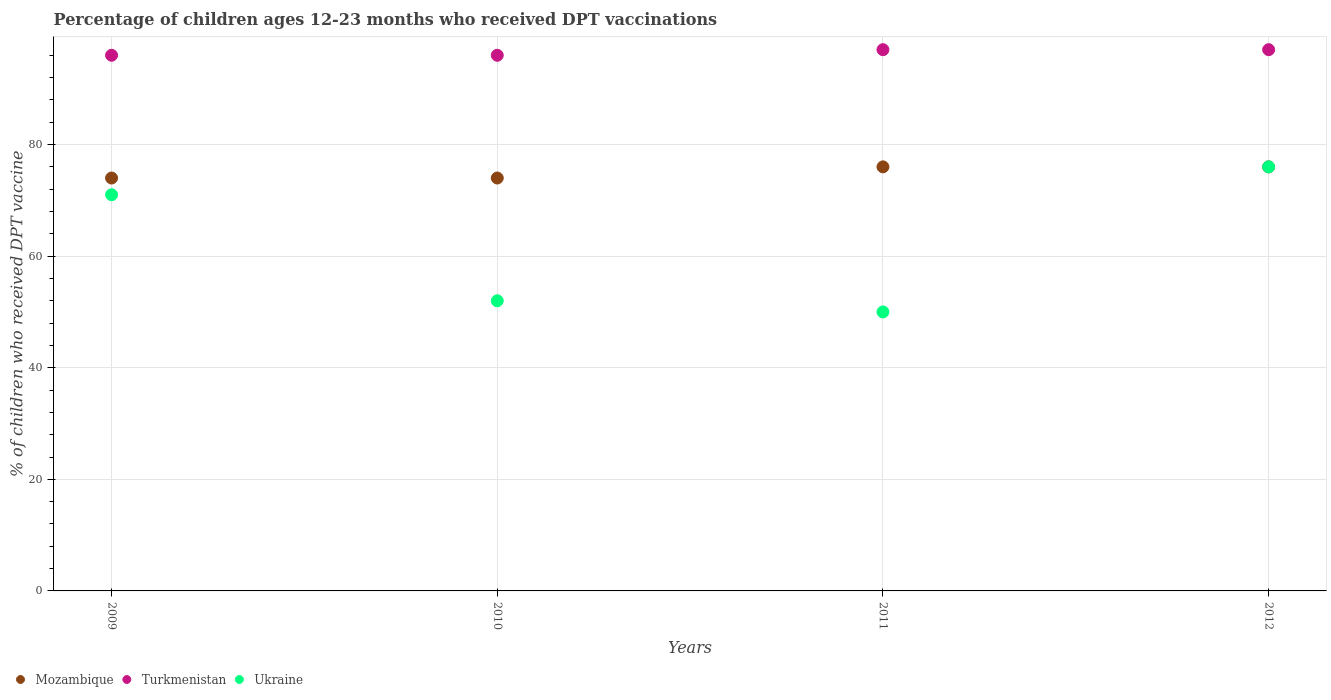How many different coloured dotlines are there?
Offer a very short reply. 3. Is the number of dotlines equal to the number of legend labels?
Offer a very short reply. Yes. Across all years, what is the maximum percentage of children who received DPT vaccination in Mozambique?
Offer a very short reply. 76. Across all years, what is the minimum percentage of children who received DPT vaccination in Mozambique?
Your response must be concise. 74. What is the total percentage of children who received DPT vaccination in Ukraine in the graph?
Your answer should be compact. 249. What is the difference between the percentage of children who received DPT vaccination in Mozambique in 2011 and that in 2012?
Provide a short and direct response. 0. In how many years, is the percentage of children who received DPT vaccination in Turkmenistan greater than 32 %?
Give a very brief answer. 4. What is the ratio of the percentage of children who received DPT vaccination in Turkmenistan in 2010 to that in 2012?
Your answer should be very brief. 0.99. Is the percentage of children who received DPT vaccination in Mozambique in 2009 less than that in 2011?
Your answer should be compact. Yes. What is the difference between the highest and the lowest percentage of children who received DPT vaccination in Mozambique?
Offer a terse response. 2. Is the sum of the percentage of children who received DPT vaccination in Mozambique in 2009 and 2011 greater than the maximum percentage of children who received DPT vaccination in Turkmenistan across all years?
Give a very brief answer. Yes. Is it the case that in every year, the sum of the percentage of children who received DPT vaccination in Turkmenistan and percentage of children who received DPT vaccination in Mozambique  is greater than the percentage of children who received DPT vaccination in Ukraine?
Make the answer very short. Yes. Does the percentage of children who received DPT vaccination in Turkmenistan monotonically increase over the years?
Your answer should be very brief. No. Where does the legend appear in the graph?
Make the answer very short. Bottom left. How many legend labels are there?
Keep it short and to the point. 3. How are the legend labels stacked?
Ensure brevity in your answer.  Horizontal. What is the title of the graph?
Your answer should be very brief. Percentage of children ages 12-23 months who received DPT vaccinations. Does "High income: OECD" appear as one of the legend labels in the graph?
Give a very brief answer. No. What is the label or title of the Y-axis?
Provide a short and direct response. % of children who received DPT vaccine. What is the % of children who received DPT vaccine of Turkmenistan in 2009?
Give a very brief answer. 96. What is the % of children who received DPT vaccine in Turkmenistan in 2010?
Your answer should be very brief. 96. What is the % of children who received DPT vaccine in Mozambique in 2011?
Your response must be concise. 76. What is the % of children who received DPT vaccine of Turkmenistan in 2011?
Offer a terse response. 97. What is the % of children who received DPT vaccine of Turkmenistan in 2012?
Keep it short and to the point. 97. Across all years, what is the maximum % of children who received DPT vaccine in Mozambique?
Offer a very short reply. 76. Across all years, what is the maximum % of children who received DPT vaccine of Turkmenistan?
Offer a very short reply. 97. Across all years, what is the minimum % of children who received DPT vaccine in Mozambique?
Provide a succinct answer. 74. Across all years, what is the minimum % of children who received DPT vaccine in Turkmenistan?
Offer a terse response. 96. What is the total % of children who received DPT vaccine of Mozambique in the graph?
Give a very brief answer. 300. What is the total % of children who received DPT vaccine in Turkmenistan in the graph?
Ensure brevity in your answer.  386. What is the total % of children who received DPT vaccine of Ukraine in the graph?
Offer a terse response. 249. What is the difference between the % of children who received DPT vaccine of Turkmenistan in 2009 and that in 2010?
Ensure brevity in your answer.  0. What is the difference between the % of children who received DPT vaccine in Ukraine in 2009 and that in 2010?
Keep it short and to the point. 19. What is the difference between the % of children who received DPT vaccine in Mozambique in 2009 and that in 2011?
Ensure brevity in your answer.  -2. What is the difference between the % of children who received DPT vaccine in Turkmenistan in 2010 and that in 2011?
Offer a terse response. -1. What is the difference between the % of children who received DPT vaccine in Mozambique in 2010 and that in 2012?
Your response must be concise. -2. What is the difference between the % of children who received DPT vaccine in Ukraine in 2010 and that in 2012?
Keep it short and to the point. -24. What is the difference between the % of children who received DPT vaccine of Turkmenistan in 2011 and that in 2012?
Provide a succinct answer. 0. What is the difference between the % of children who received DPT vaccine in Mozambique in 2009 and the % of children who received DPT vaccine in Turkmenistan in 2011?
Provide a succinct answer. -23. What is the difference between the % of children who received DPT vaccine in Mozambique in 2009 and the % of children who received DPT vaccine in Ukraine in 2012?
Provide a short and direct response. -2. What is the difference between the % of children who received DPT vaccine in Turkmenistan in 2009 and the % of children who received DPT vaccine in Ukraine in 2012?
Your answer should be compact. 20. What is the difference between the % of children who received DPT vaccine of Mozambique in 2010 and the % of children who received DPT vaccine of Turkmenistan in 2011?
Offer a very short reply. -23. What is the difference between the % of children who received DPT vaccine in Turkmenistan in 2010 and the % of children who received DPT vaccine in Ukraine in 2011?
Keep it short and to the point. 46. What is the difference between the % of children who received DPT vaccine in Mozambique in 2010 and the % of children who received DPT vaccine in Turkmenistan in 2012?
Offer a very short reply. -23. What is the difference between the % of children who received DPT vaccine of Mozambique in 2010 and the % of children who received DPT vaccine of Ukraine in 2012?
Your response must be concise. -2. What is the difference between the % of children who received DPT vaccine in Turkmenistan in 2010 and the % of children who received DPT vaccine in Ukraine in 2012?
Provide a succinct answer. 20. What is the difference between the % of children who received DPT vaccine of Mozambique in 2011 and the % of children who received DPT vaccine of Ukraine in 2012?
Keep it short and to the point. 0. What is the difference between the % of children who received DPT vaccine in Turkmenistan in 2011 and the % of children who received DPT vaccine in Ukraine in 2012?
Give a very brief answer. 21. What is the average % of children who received DPT vaccine of Mozambique per year?
Make the answer very short. 75. What is the average % of children who received DPT vaccine in Turkmenistan per year?
Make the answer very short. 96.5. What is the average % of children who received DPT vaccine in Ukraine per year?
Your answer should be very brief. 62.25. In the year 2009, what is the difference between the % of children who received DPT vaccine of Mozambique and % of children who received DPT vaccine of Turkmenistan?
Offer a terse response. -22. In the year 2009, what is the difference between the % of children who received DPT vaccine of Mozambique and % of children who received DPT vaccine of Ukraine?
Provide a succinct answer. 3. In the year 2009, what is the difference between the % of children who received DPT vaccine in Turkmenistan and % of children who received DPT vaccine in Ukraine?
Provide a succinct answer. 25. In the year 2010, what is the difference between the % of children who received DPT vaccine of Mozambique and % of children who received DPT vaccine of Turkmenistan?
Keep it short and to the point. -22. In the year 2010, what is the difference between the % of children who received DPT vaccine of Mozambique and % of children who received DPT vaccine of Ukraine?
Your answer should be compact. 22. In the year 2011, what is the difference between the % of children who received DPT vaccine of Mozambique and % of children who received DPT vaccine of Turkmenistan?
Ensure brevity in your answer.  -21. In the year 2011, what is the difference between the % of children who received DPT vaccine of Mozambique and % of children who received DPT vaccine of Ukraine?
Ensure brevity in your answer.  26. In the year 2011, what is the difference between the % of children who received DPT vaccine in Turkmenistan and % of children who received DPT vaccine in Ukraine?
Your answer should be very brief. 47. In the year 2012, what is the difference between the % of children who received DPT vaccine of Mozambique and % of children who received DPT vaccine of Turkmenistan?
Provide a short and direct response. -21. In the year 2012, what is the difference between the % of children who received DPT vaccine in Mozambique and % of children who received DPT vaccine in Ukraine?
Give a very brief answer. 0. In the year 2012, what is the difference between the % of children who received DPT vaccine in Turkmenistan and % of children who received DPT vaccine in Ukraine?
Provide a short and direct response. 21. What is the ratio of the % of children who received DPT vaccine in Turkmenistan in 2009 to that in 2010?
Your answer should be compact. 1. What is the ratio of the % of children who received DPT vaccine in Ukraine in 2009 to that in 2010?
Make the answer very short. 1.37. What is the ratio of the % of children who received DPT vaccine of Mozambique in 2009 to that in 2011?
Your response must be concise. 0.97. What is the ratio of the % of children who received DPT vaccine in Ukraine in 2009 to that in 2011?
Your answer should be compact. 1.42. What is the ratio of the % of children who received DPT vaccine of Mozambique in 2009 to that in 2012?
Offer a terse response. 0.97. What is the ratio of the % of children who received DPT vaccine in Turkmenistan in 2009 to that in 2012?
Make the answer very short. 0.99. What is the ratio of the % of children who received DPT vaccine in Ukraine in 2009 to that in 2012?
Your response must be concise. 0.93. What is the ratio of the % of children who received DPT vaccine in Mozambique in 2010 to that in 2011?
Keep it short and to the point. 0.97. What is the ratio of the % of children who received DPT vaccine of Ukraine in 2010 to that in 2011?
Provide a short and direct response. 1.04. What is the ratio of the % of children who received DPT vaccine in Mozambique in 2010 to that in 2012?
Offer a terse response. 0.97. What is the ratio of the % of children who received DPT vaccine of Ukraine in 2010 to that in 2012?
Offer a very short reply. 0.68. What is the ratio of the % of children who received DPT vaccine in Turkmenistan in 2011 to that in 2012?
Offer a terse response. 1. What is the ratio of the % of children who received DPT vaccine of Ukraine in 2011 to that in 2012?
Ensure brevity in your answer.  0.66. What is the difference between the highest and the second highest % of children who received DPT vaccine of Mozambique?
Offer a terse response. 0. What is the difference between the highest and the lowest % of children who received DPT vaccine of Mozambique?
Provide a succinct answer. 2. 